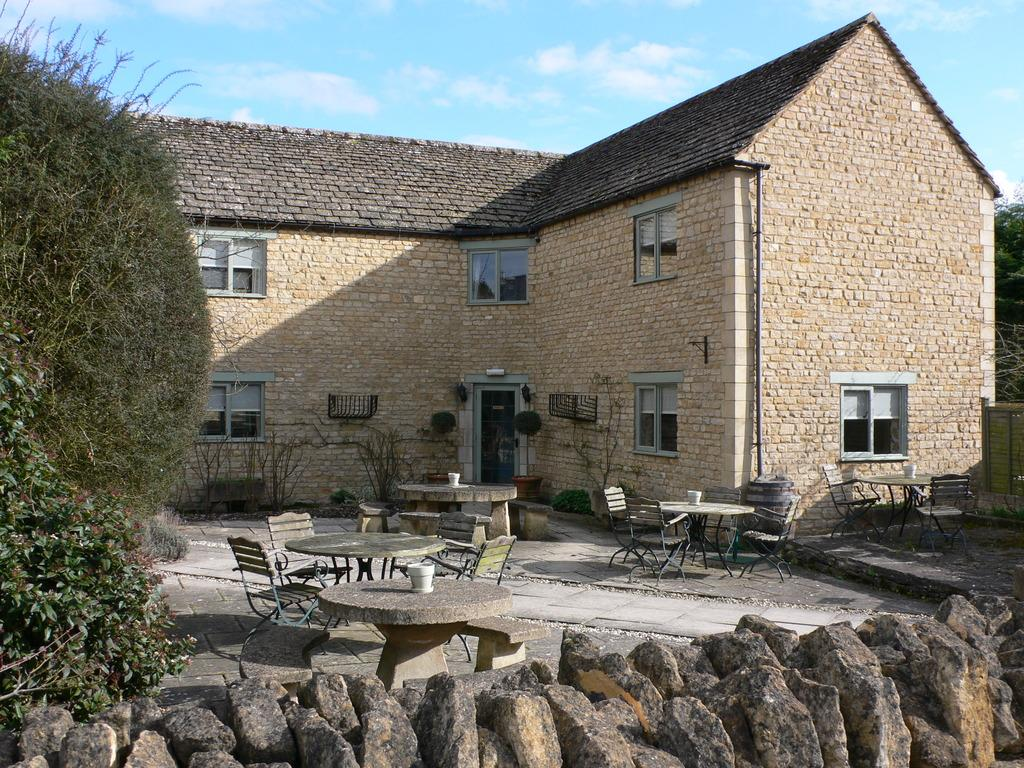What is the main structure in the middle of the image? There is a building in the middle of the image. What features can be seen on the building? The building has doors and windows. What type of vegetation is on the left side of the image? There are trees on the left side of the image. What type of furniture is in the middle of the image? There are tables in the middle of the image. What type of seating is near the tables? There are chairs near the tables. What year is depicted on the toy in the image? There is no toy present in the image, so it is not possible to determine the year depicted on a toy. 